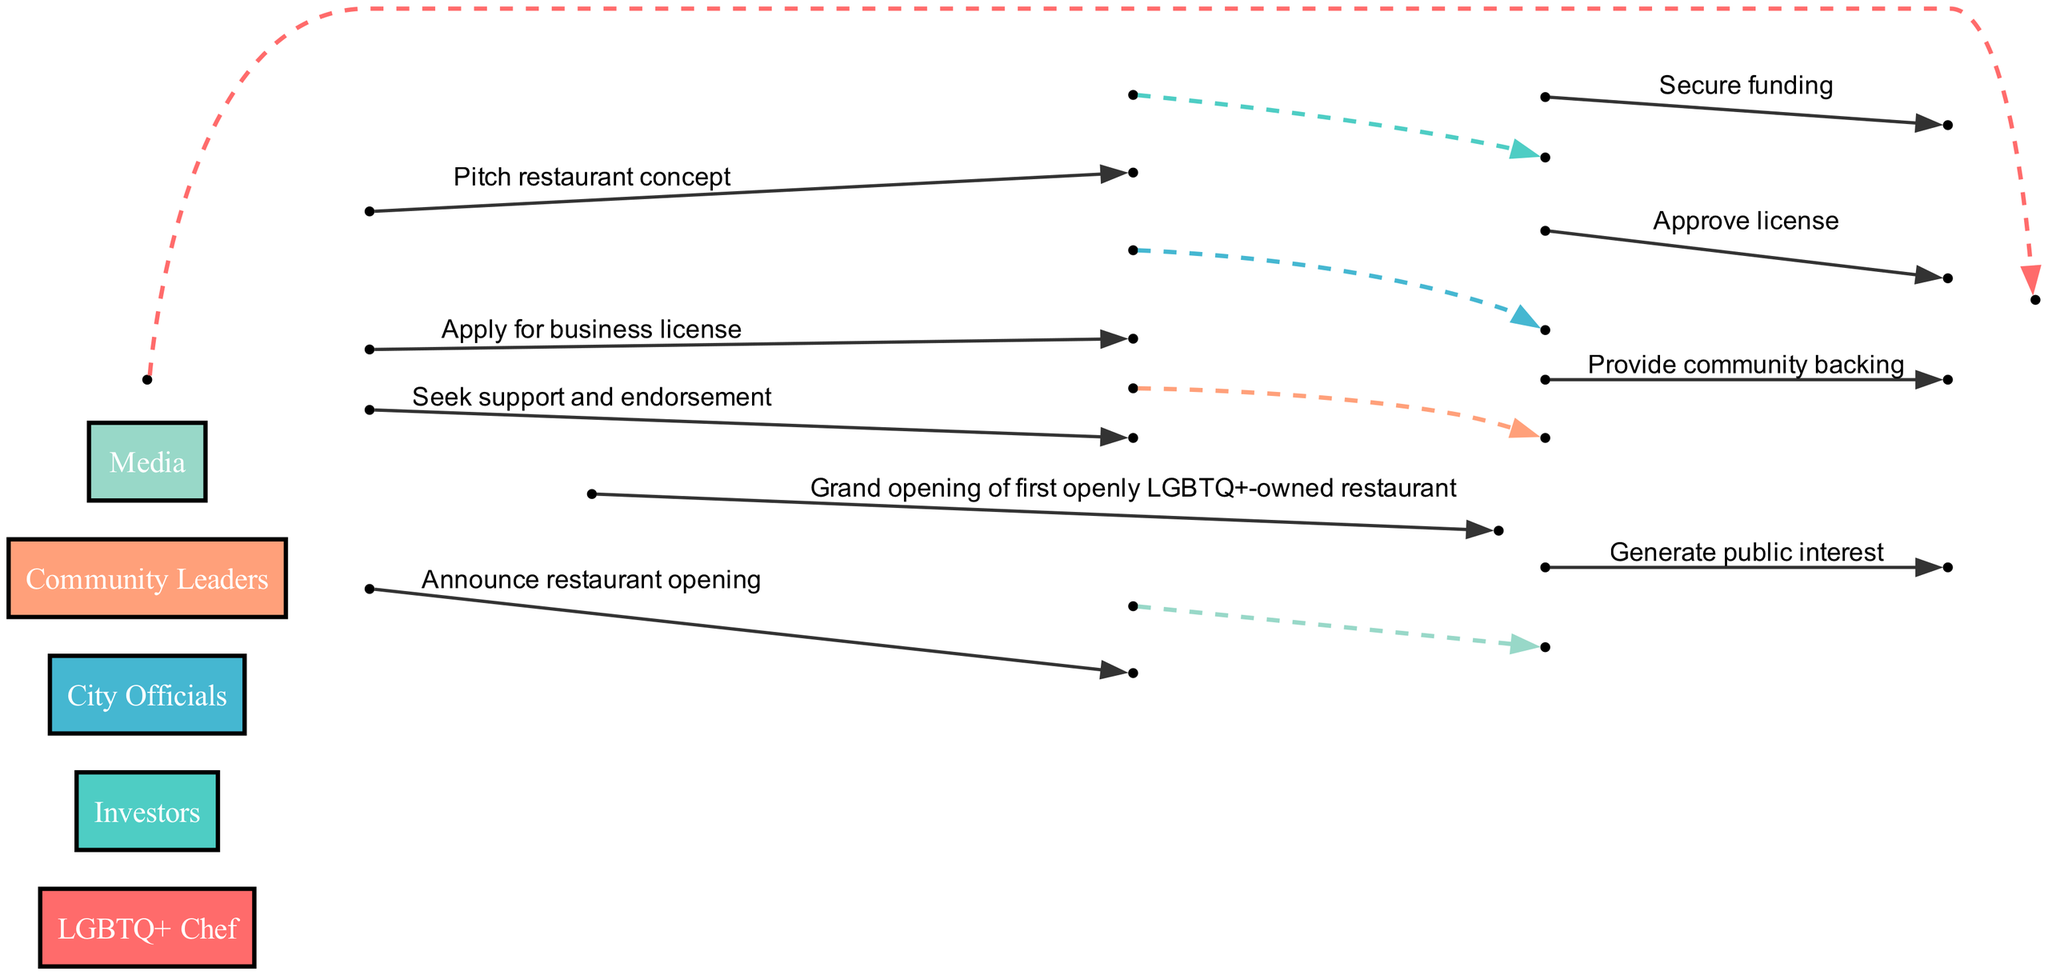What is the first action taken by the LGBTQ+ Chef? The LGBTQ+ Chef first takes the action to pitch the restaurant concept to investors. This can be seen at the beginning of the sequence where the chef initiates the process.
Answer: Pitch restaurant concept How many main actors are involved in the sequence? The diagram lists five main actors: LGBTQ+ Chef, Investors, City Officials, Community Leaders, and Media. You can count each actor represented in the diagram.
Answer: Five What does the Community Leaders provide to the LGBTQ+ Chef? The Community Leaders provide community backing to the LGBTQ+ Chef. This is indicated in the sequence where a direct line shows their interaction.
Answer: Provide community backing What is the last action in the sequence? The last action performed in the sequence is the grand opening of the first openly LGBTQ+-owned restaurant. It concludes the series of events shown in the diagram clearly marked as the final event.
Answer: Grand opening of first openly LGBTQ+-owned restaurant Which actor secures funding for the project? The funding for the project is secured by the investors. This is described in the sequence where the investors respond to the LGBTQ+ Chef’s pitch.
Answer: Investors Who does the LGBTQ+ Chef apply for a business license to? The LGBTQ+ Chef applies for a business license to city officials, as indicated by the directional flow from the chef to the officials in the diagram.
Answer: City Officials How many actions are completed before the announcement to the media? There are three actions completed before the announcement to the media: pitching the concept, securing funding, and applying for a business license. Counting each event before the announcement provides this answer.
Answer: Three What generates public interest for the restaurant? Public interest is generated by the media, as shown in the sequence where the media responds to the chef's announcement. This highlights the media's role in creating buzz for the opening.
Answer: Generate public interest 